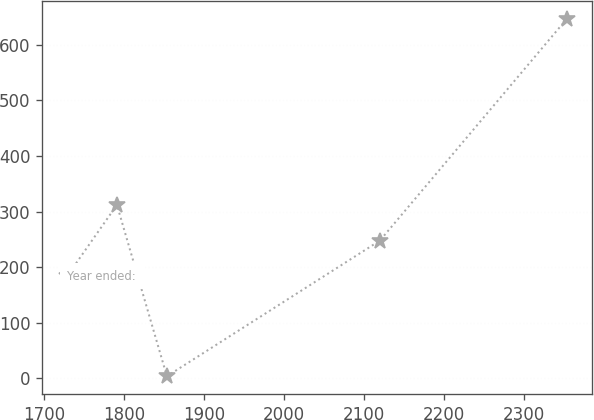Convert chart. <chart><loc_0><loc_0><loc_500><loc_500><line_chart><ecel><fcel>Year ended:<nl><fcel>1728.86<fcel>183.38<nl><fcel>1791.34<fcel>312.04<nl><fcel>1853.82<fcel>3.47<nl><fcel>2120.07<fcel>247.71<nl><fcel>2353.67<fcel>646.81<nl></chart> 